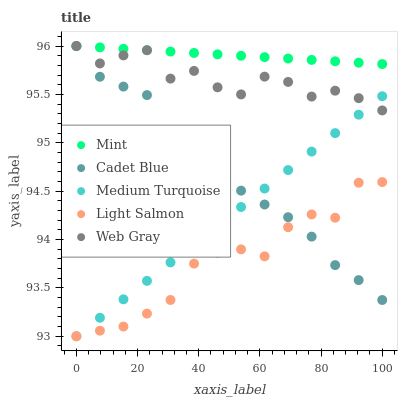Does Light Salmon have the minimum area under the curve?
Answer yes or no. Yes. Does Mint have the maximum area under the curve?
Answer yes or no. Yes. Does Cadet Blue have the minimum area under the curve?
Answer yes or no. No. Does Cadet Blue have the maximum area under the curve?
Answer yes or no. No. Is Medium Turquoise the smoothest?
Answer yes or no. Yes. Is Web Gray the roughest?
Answer yes or no. Yes. Is Light Salmon the smoothest?
Answer yes or no. No. Is Light Salmon the roughest?
Answer yes or no. No. Does Light Salmon have the lowest value?
Answer yes or no. Yes. Does Cadet Blue have the lowest value?
Answer yes or no. No. Does Mint have the highest value?
Answer yes or no. Yes. Does Light Salmon have the highest value?
Answer yes or no. No. Is Medium Turquoise less than Mint?
Answer yes or no. Yes. Is Web Gray greater than Light Salmon?
Answer yes or no. Yes. Does Cadet Blue intersect Mint?
Answer yes or no. Yes. Is Cadet Blue less than Mint?
Answer yes or no. No. Is Cadet Blue greater than Mint?
Answer yes or no. No. Does Medium Turquoise intersect Mint?
Answer yes or no. No. 